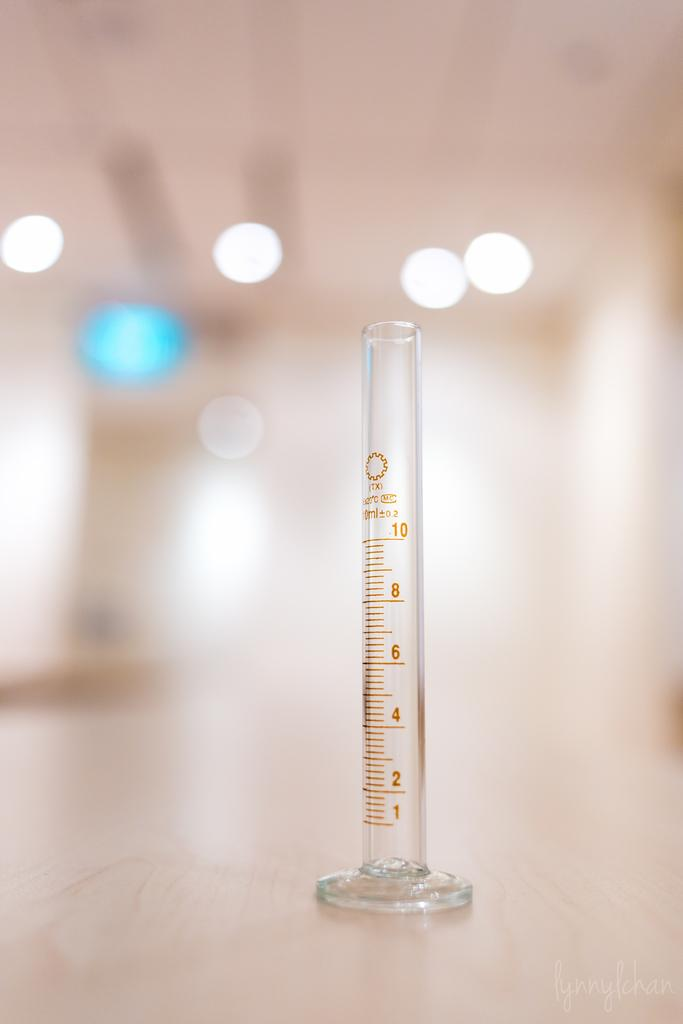<image>
Give a short and clear explanation of the subsequent image. 10 centimeters is the highest level to measure with this instrument. 